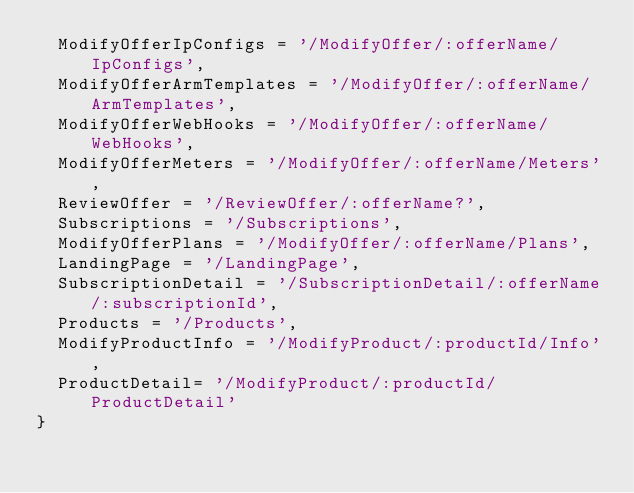Convert code to text. <code><loc_0><loc_0><loc_500><loc_500><_TypeScript_>  ModifyOfferIpConfigs = '/ModifyOffer/:offerName/IpConfigs',
  ModifyOfferArmTemplates = '/ModifyOffer/:offerName/ArmTemplates',
  ModifyOfferWebHooks = '/ModifyOffer/:offerName/WebHooks',
  ModifyOfferMeters = '/ModifyOffer/:offerName/Meters',
  ReviewOffer = '/ReviewOffer/:offerName?',
  Subscriptions = '/Subscriptions',
  ModifyOfferPlans = '/ModifyOffer/:offerName/Plans',
  LandingPage = '/LandingPage',
  SubscriptionDetail = '/SubscriptionDetail/:offerName/:subscriptionId',
  Products = '/Products',
  ModifyProductInfo = '/ModifyProduct/:productId/Info',
  ProductDetail= '/ModifyProduct/:productId/ProductDetail'
}</code> 